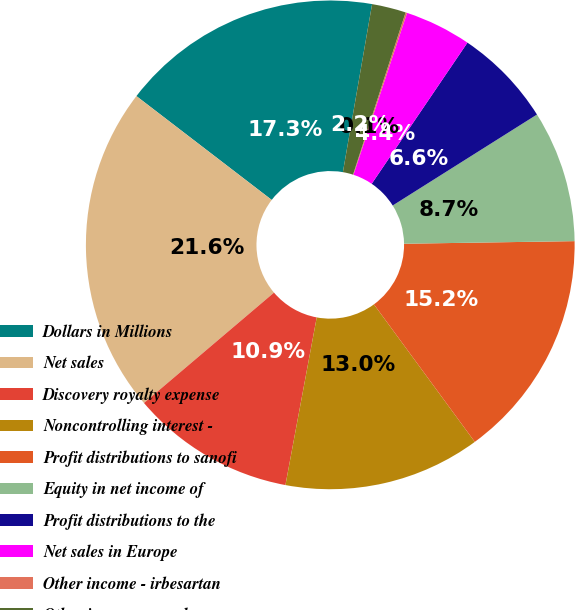Convert chart to OTSL. <chart><loc_0><loc_0><loc_500><loc_500><pie_chart><fcel>Dollars in Millions<fcel>Net sales<fcel>Discovery royalty expense<fcel>Noncontrolling interest -<fcel>Profit distributions to sanofi<fcel>Equity in net income of<fcel>Profit distributions to the<fcel>Net sales in Europe<fcel>Other income - irbesartan<fcel>Other income - supply<nl><fcel>17.32%<fcel>21.62%<fcel>10.86%<fcel>13.01%<fcel>15.17%<fcel>8.71%<fcel>6.56%<fcel>4.4%<fcel>0.1%<fcel>2.25%<nl></chart> 